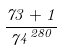<formula> <loc_0><loc_0><loc_500><loc_500>\frac { 7 3 + 1 } { { 7 ^ { 4 } } ^ { 2 8 0 } }</formula> 